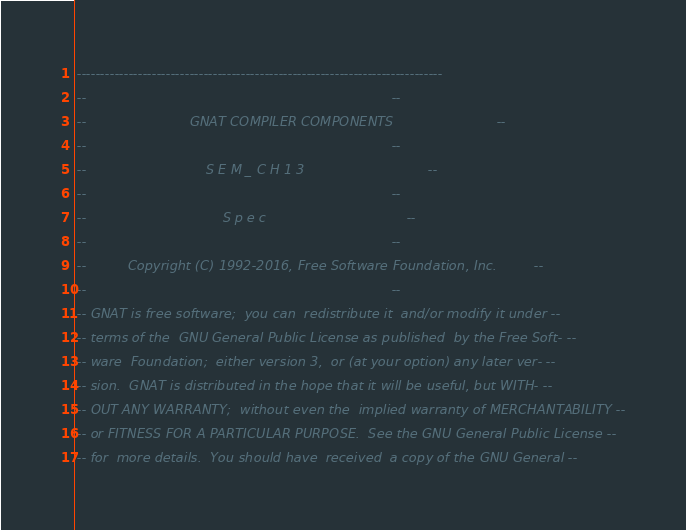<code> <loc_0><loc_0><loc_500><loc_500><_Ada_>------------------------------------------------------------------------------
--                                                                          --
--                         GNAT COMPILER COMPONENTS                         --
--                                                                          --
--                             S E M _ C H 1 3                              --
--                                                                          --
--                                 S p e c                                  --
--                                                                          --
--          Copyright (C) 1992-2016, Free Software Foundation, Inc.         --
--                                                                          --
-- GNAT is free software;  you can  redistribute it  and/or modify it under --
-- terms of the  GNU General Public License as published  by the Free Soft- --
-- ware  Foundation;  either version 3,  or (at your option) any later ver- --
-- sion.  GNAT is distributed in the hope that it will be useful, but WITH- --
-- OUT ANY WARRANTY;  without even the  implied warranty of MERCHANTABILITY --
-- or FITNESS FOR A PARTICULAR PURPOSE.  See the GNU General Public License --
-- for  more details.  You should have  received  a copy of the GNU General --</code> 